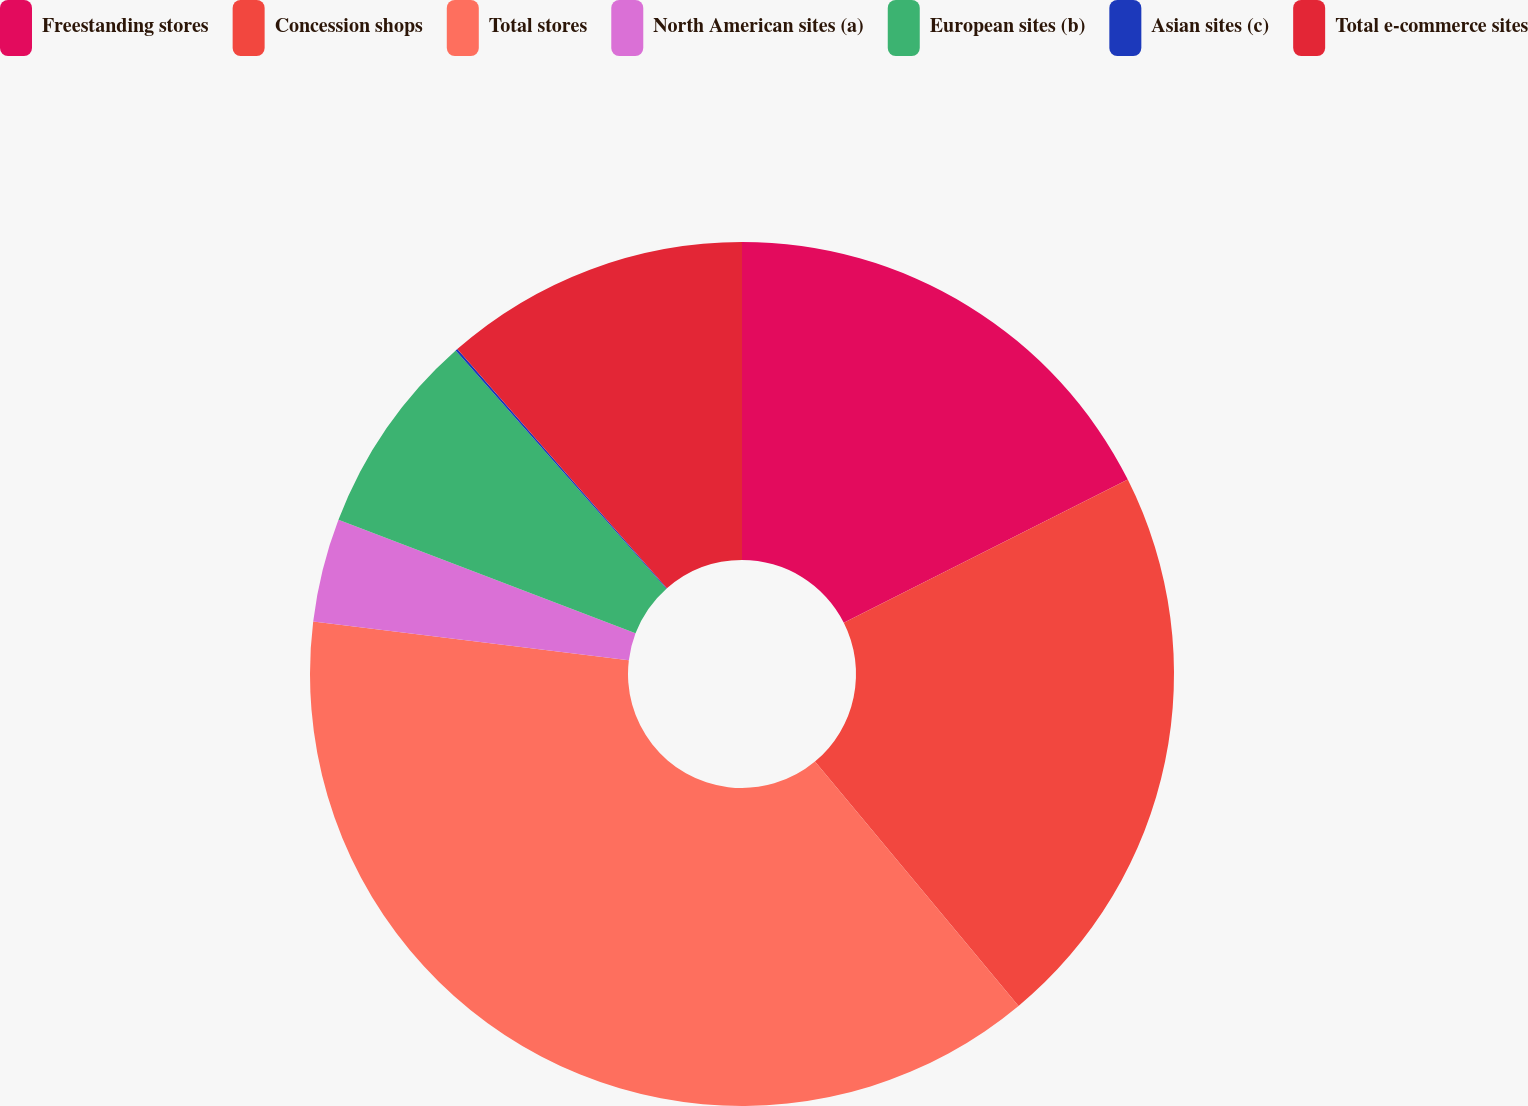Convert chart to OTSL. <chart><loc_0><loc_0><loc_500><loc_500><pie_chart><fcel>Freestanding stores<fcel>Concession shops<fcel>Total stores<fcel>North American sites (a)<fcel>European sites (b)<fcel>Asian sites (c)<fcel>Total e-commerce sites<nl><fcel>17.57%<fcel>21.37%<fcel>37.99%<fcel>3.87%<fcel>7.66%<fcel>0.08%<fcel>11.45%<nl></chart> 